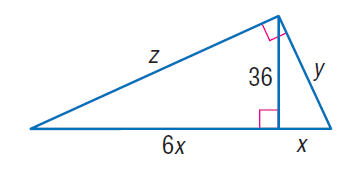Answer the mathemtical geometry problem and directly provide the correct option letter.
Question: Find y.
Choices: A: 3 \sqrt { 42 } B: 6 \sqrt { 42 } C: 48 D: 60 B 